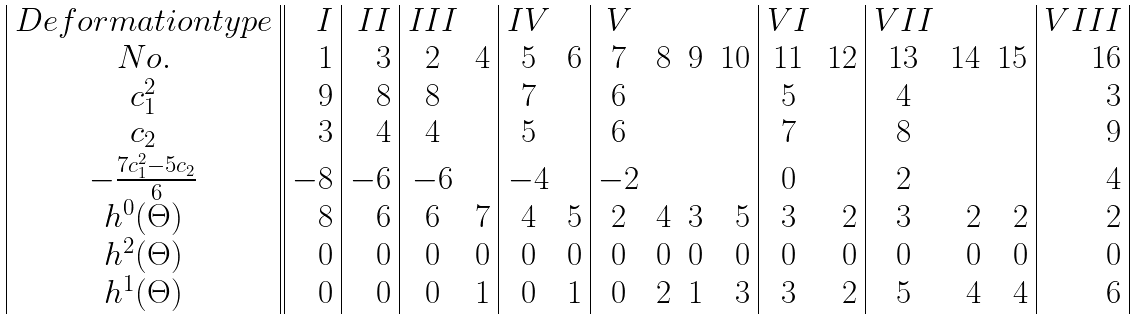<formula> <loc_0><loc_0><loc_500><loc_500>\begin{array} { | c | | r | r | c r | c r | c r r r | c r | c r r | r | } D e f o r m a t i o n t y p e & I & I I & I I I & & I V & & V & & & & V I & & V I I & & & V I I I \\ N o . & 1 & 3 & 2 & 4 & 5 & 6 & 7 & 8 & 9 & 1 0 & 1 1 & 1 2 & 1 3 & 1 4 & 1 5 & 1 6 \\ c _ { 1 } ^ { 2 } & 9 & 8 & 8 & & 7 & & 6 & & & & 5 & & 4 & & & 3 \\ c _ { 2 } & 3 & 4 & 4 & & 5 & & 6 & & & & 7 & & 8 & & & 9 \\ - \frac { 7 c _ { 1 } ^ { 2 } - 5 c _ { 2 } } { 6 } & - 8 & - 6 & - 6 & & - 4 & & - 2 & & & & 0 & & 2 & & & 4 \\ h ^ { 0 } ( \Theta ) & 8 & 6 & 6 & 7 & 4 & 5 & 2 & 4 & 3 & 5 & 3 & 2 & 3 & 2 & 2 & 2 \\ h ^ { 2 } ( \Theta ) & 0 & 0 & 0 & 0 & 0 & 0 & 0 & 0 & 0 & 0 & 0 & 0 & 0 & 0 & 0 & 0 \\ h ^ { 1 } ( \Theta ) & 0 & 0 & 0 & 1 & 0 & 1 & 0 & 2 & 1 & 3 & 3 & 2 & 5 & 4 & 4 & 6 \\ \end{array}</formula> 